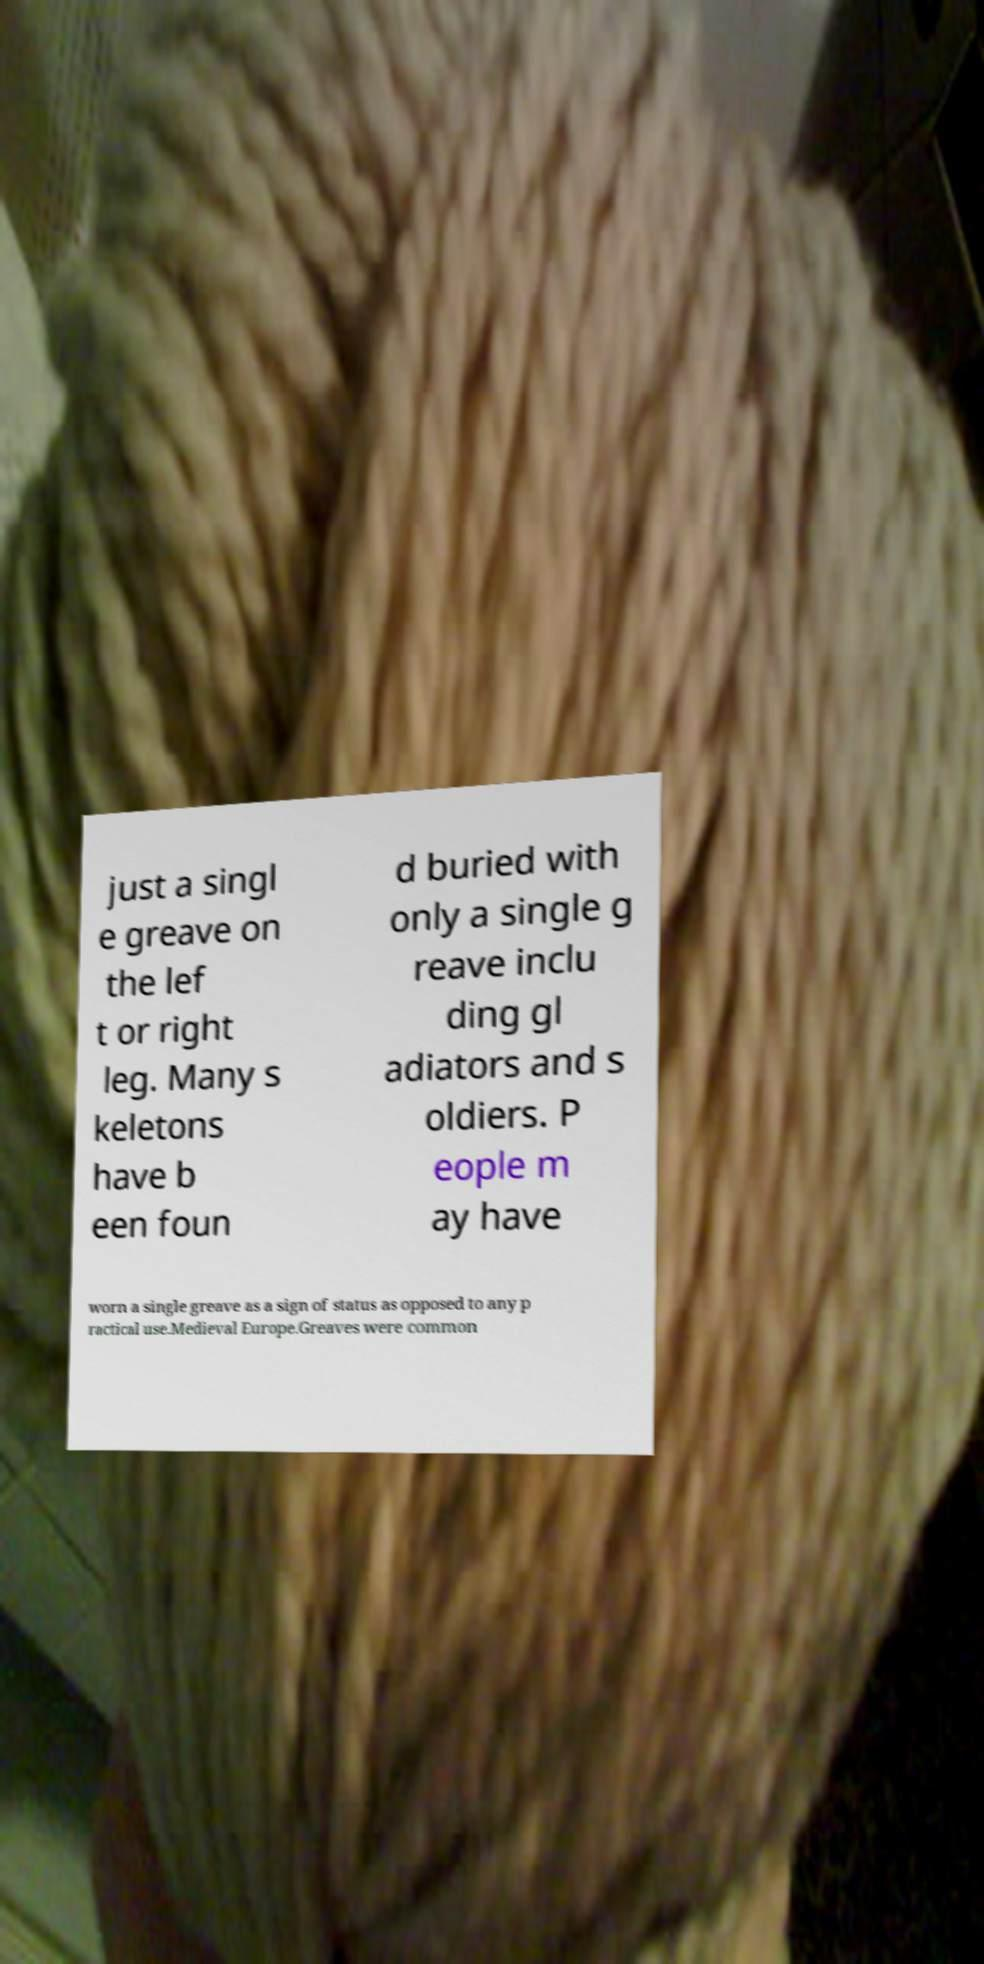Can you read and provide the text displayed in the image?This photo seems to have some interesting text. Can you extract and type it out for me? just a singl e greave on the lef t or right leg. Many s keletons have b een foun d buried with only a single g reave inclu ding gl adiators and s oldiers. P eople m ay have worn a single greave as a sign of status as opposed to any p ractical use.Medieval Europe.Greaves were common 